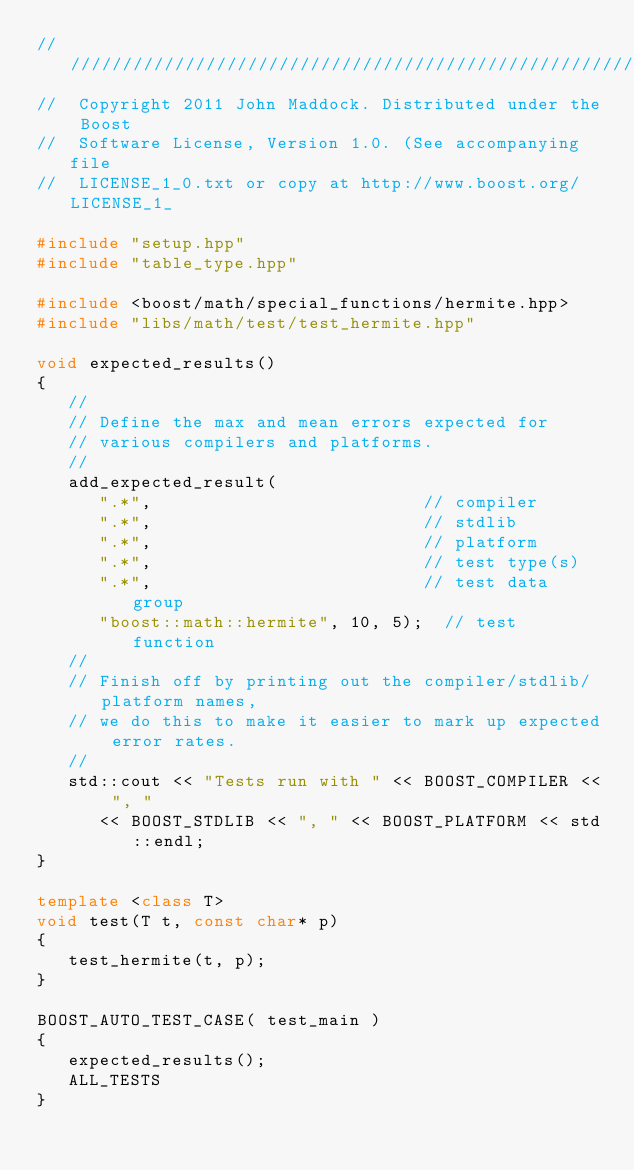<code> <loc_0><loc_0><loc_500><loc_500><_C++_>///////////////////////////////////////////////////////////////
//  Copyright 2011 John Maddock. Distributed under the Boost
//  Software License, Version 1.0. (See accompanying file
//  LICENSE_1_0.txt or copy at http://www.boost.org/LICENSE_1_

#include "setup.hpp"
#include "table_type.hpp"

#include <boost/math/special_functions/hermite.hpp>
#include "libs/math/test/test_hermite.hpp"

void expected_results()
{
   //
   // Define the max and mean errors expected for
   // various compilers and platforms.
   //
   add_expected_result(
      ".*",                          // compiler
      ".*",                          // stdlib
      ".*",                          // platform
      ".*",                          // test type(s)
      ".*",                          // test data group
      "boost::math::hermite", 10, 5);  // test function
   //
   // Finish off by printing out the compiler/stdlib/platform names,
   // we do this to make it easier to mark up expected error rates.
   //
   std::cout << "Tests run with " << BOOST_COMPILER << ", "
      << BOOST_STDLIB << ", " << BOOST_PLATFORM << std::endl;
}

template <class T>
void test(T t, const char* p)
{
   test_hermite(t, p);
}

BOOST_AUTO_TEST_CASE( test_main )
{
   expected_results();
   ALL_TESTS
}

</code> 